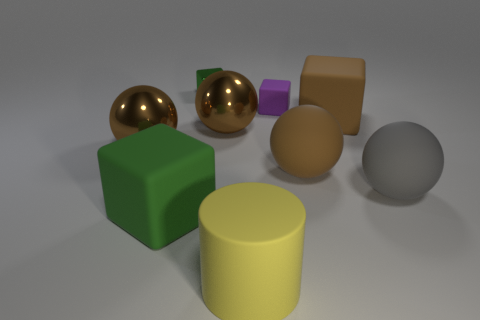What is the shape of the yellow object?
Provide a short and direct response. Cylinder. Are there any tiny things of the same color as the small matte block?
Make the answer very short. No. Is the number of brown objects that are on the right side of the yellow cylinder greater than the number of large blue blocks?
Offer a terse response. Yes. There is a purple matte object; does it have the same shape as the large yellow object in front of the small purple matte cube?
Provide a succinct answer. No. Is there a yellow metal ball?
Your answer should be compact. No. How many big things are brown blocks or matte cylinders?
Make the answer very short. 2. Are there more big objects on the right side of the purple matte cube than spheres to the left of the yellow thing?
Provide a short and direct response. Yes. Are the big green block and the small block behind the tiny purple matte block made of the same material?
Offer a terse response. No. The tiny matte cube has what color?
Offer a terse response. Purple. There is a large shiny object that is to the left of the green rubber cube; what is its shape?
Ensure brevity in your answer.  Sphere. 